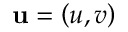Convert formula to latex. <formula><loc_0><loc_0><loc_500><loc_500>u = \left ( u , v \right )</formula> 